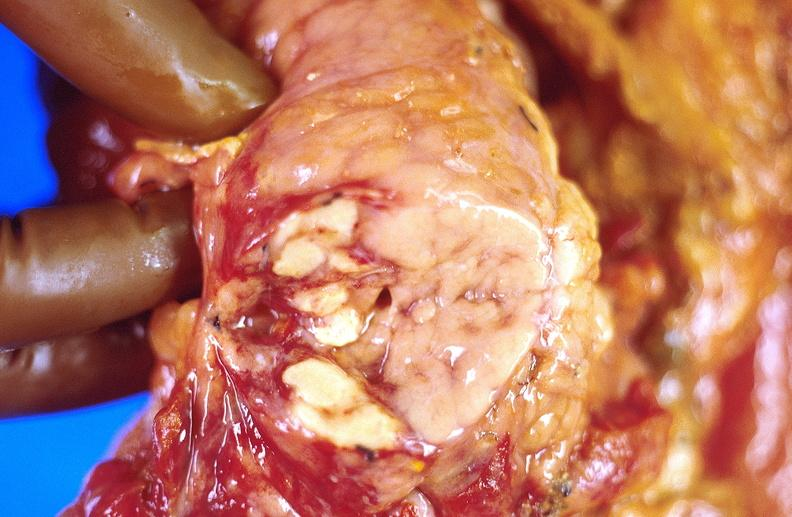does artery show pancreatic fat necrosis, transplanted pancreas?
Answer the question using a single word or phrase. No 